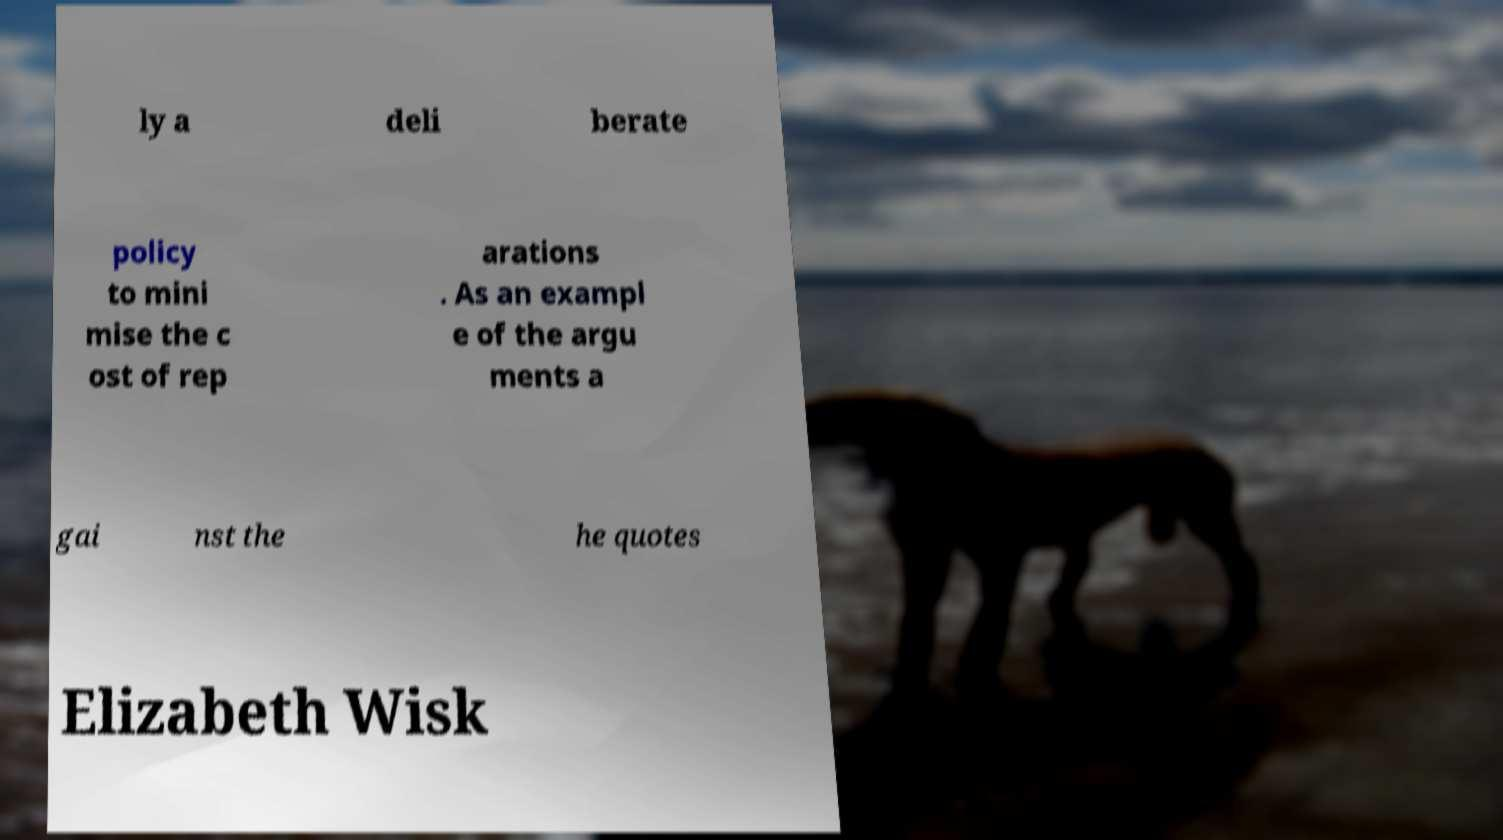Please read and relay the text visible in this image. What does it say? ly a deli berate policy to mini mise the c ost of rep arations . As an exampl e of the argu ments a gai nst the he quotes Elizabeth Wisk 